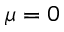Convert formula to latex. <formula><loc_0><loc_0><loc_500><loc_500>\mu = 0</formula> 